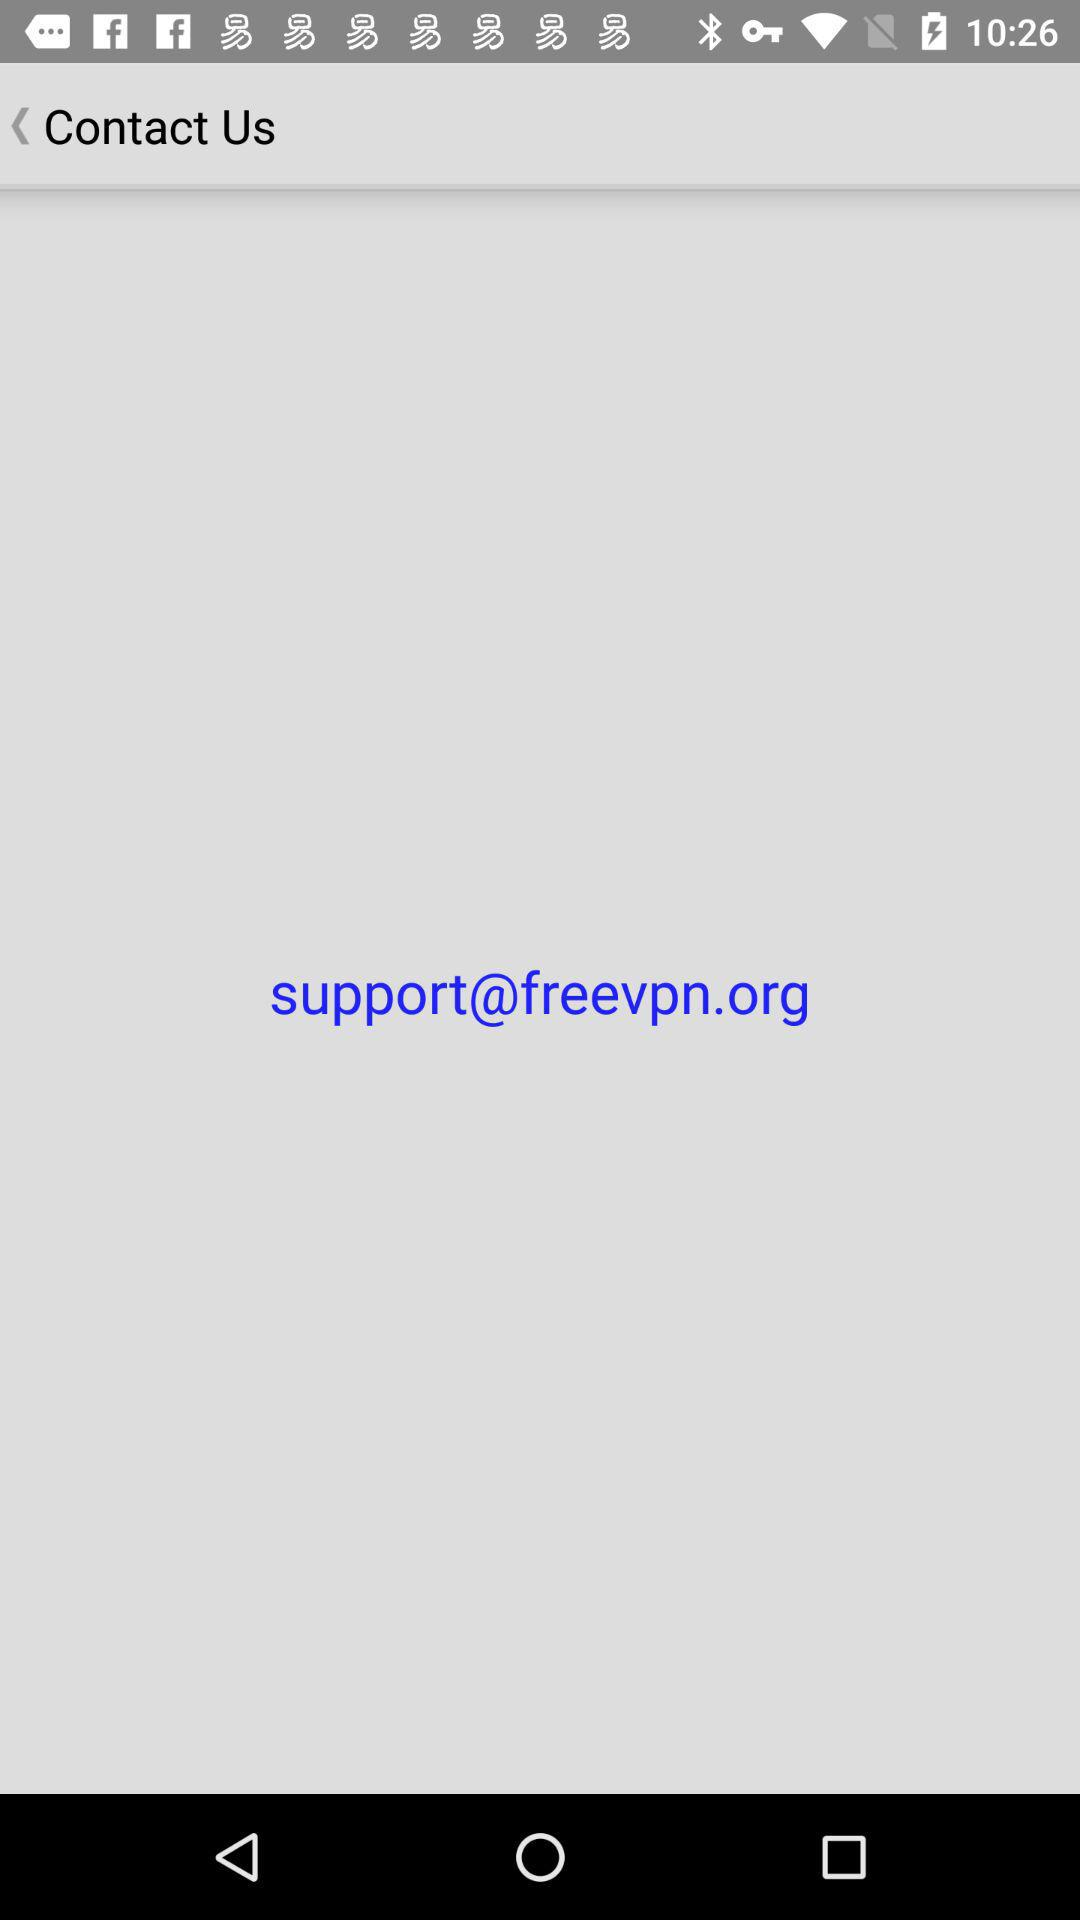What is the email address for contact? The email address is support@freevpn.org. 